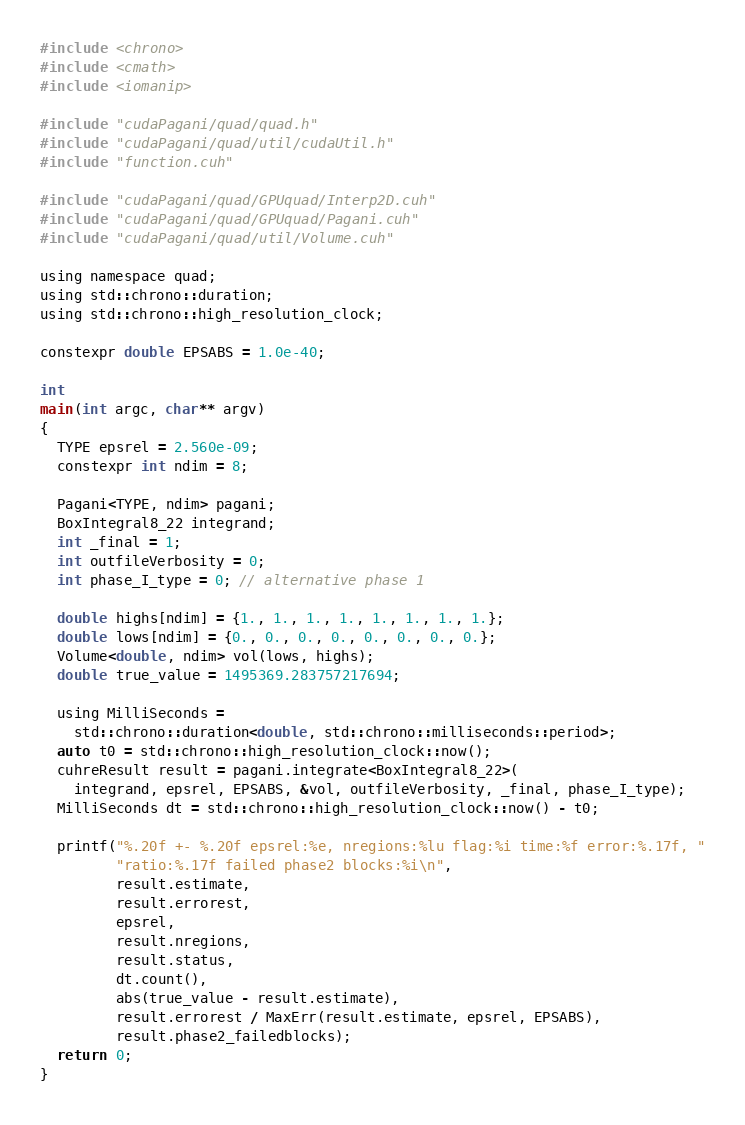Convert code to text. <code><loc_0><loc_0><loc_500><loc_500><_Cuda_>#include <chrono>
#include <cmath>
#include <iomanip>

#include "cudaPagani/quad/quad.h"
#include "cudaPagani/quad/util/cudaUtil.h"
#include "function.cuh"

#include "cudaPagani/quad/GPUquad/Interp2D.cuh"
#include "cudaPagani/quad/GPUquad/Pagani.cuh"
#include "cudaPagani/quad/util/Volume.cuh"

using namespace quad;
using std::chrono::duration;
using std::chrono::high_resolution_clock;

constexpr double EPSABS = 1.0e-40;

int
main(int argc, char** argv)
{
  TYPE epsrel = 2.560e-09;
  constexpr int ndim = 8;

  Pagani<TYPE, ndim> pagani;
  BoxIntegral8_22 integrand;
  int _final = 1;
  int outfileVerbosity = 0;
  int phase_I_type = 0; // alternative phase 1

  double highs[ndim] = {1., 1., 1., 1., 1., 1., 1., 1.};
  double lows[ndim] = {0., 0., 0., 0., 0., 0., 0., 0.};
  Volume<double, ndim> vol(lows, highs);
  double true_value = 1495369.283757217694;

  using MilliSeconds =
    std::chrono::duration<double, std::chrono::milliseconds::period>;
  auto t0 = std::chrono::high_resolution_clock::now();
  cuhreResult result = pagani.integrate<BoxIntegral8_22>(
    integrand, epsrel, EPSABS, &vol, outfileVerbosity, _final, phase_I_type);
  MilliSeconds dt = std::chrono::high_resolution_clock::now() - t0;

  printf("%.20f +- %.20f epsrel:%e, nregions:%lu flag:%i time:%f error:%.17f, "
         "ratio:%.17f failed phase2 blocks:%i\n",
         result.estimate,
         result.errorest,
         epsrel,
         result.nregions,
         result.status,
         dt.count(),
         abs(true_value - result.estimate),
         result.errorest / MaxErr(result.estimate, epsrel, EPSABS),
         result.phase2_failedblocks);
  return 0;
}
</code> 